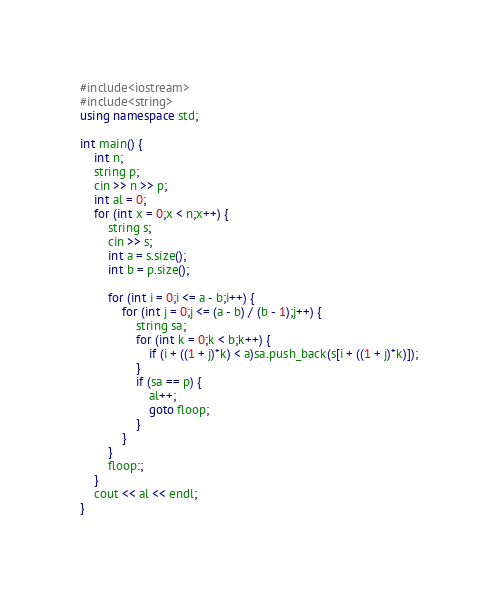<code> <loc_0><loc_0><loc_500><loc_500><_C++_>#include<iostream>
#include<string>
using namespace std;

int main() {
	int n;
	string p;
	cin >> n >> p;
	int al = 0;
	for (int x = 0;x < n;x++) {
		string s;
		cin >> s;
		int a = s.size();
		int b = p.size();

		for (int i = 0;i <= a - b;i++) {
			for (int j = 0;j <= (a - b) / (b - 1);j++) {
				string sa;
				for (int k = 0;k < b;k++) {
					if (i + ((1 + j)*k) < a)sa.push_back(s[i + ((1 + j)*k)]);
				}
				if (sa == p) {
					al++;
					goto floop;
				}
			}
		}
		floop:;
	}
	cout << al << endl;
}</code> 